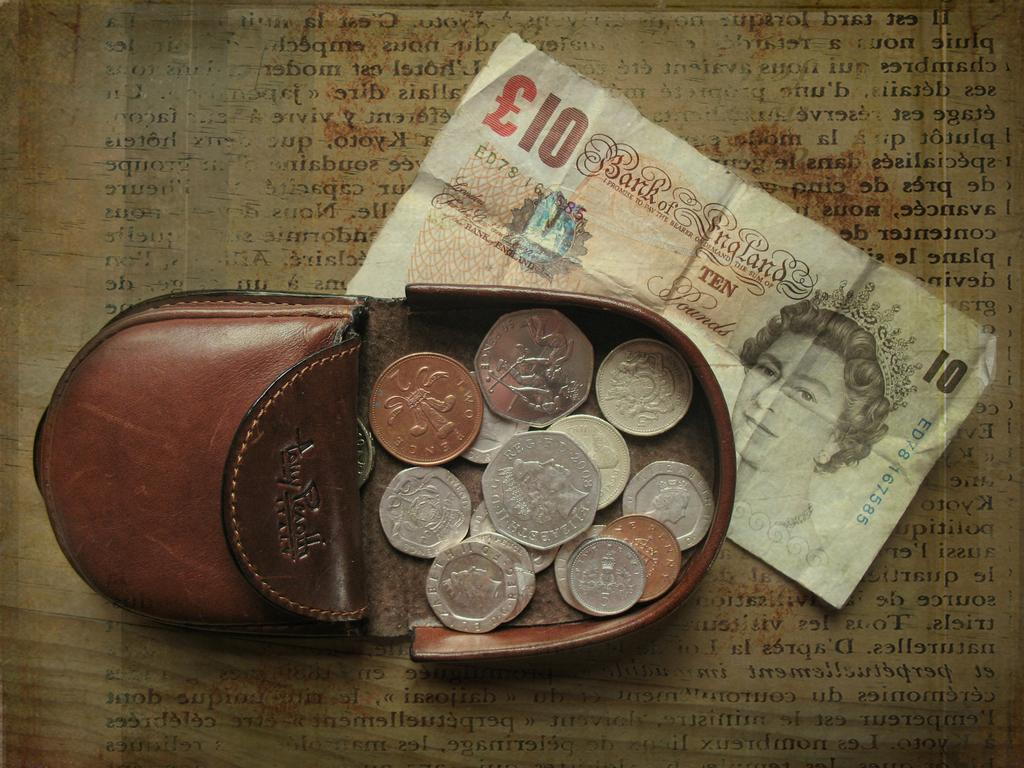Provide a one-sentence caption for the provided image. a 10 Bank of England note is under some coins. 